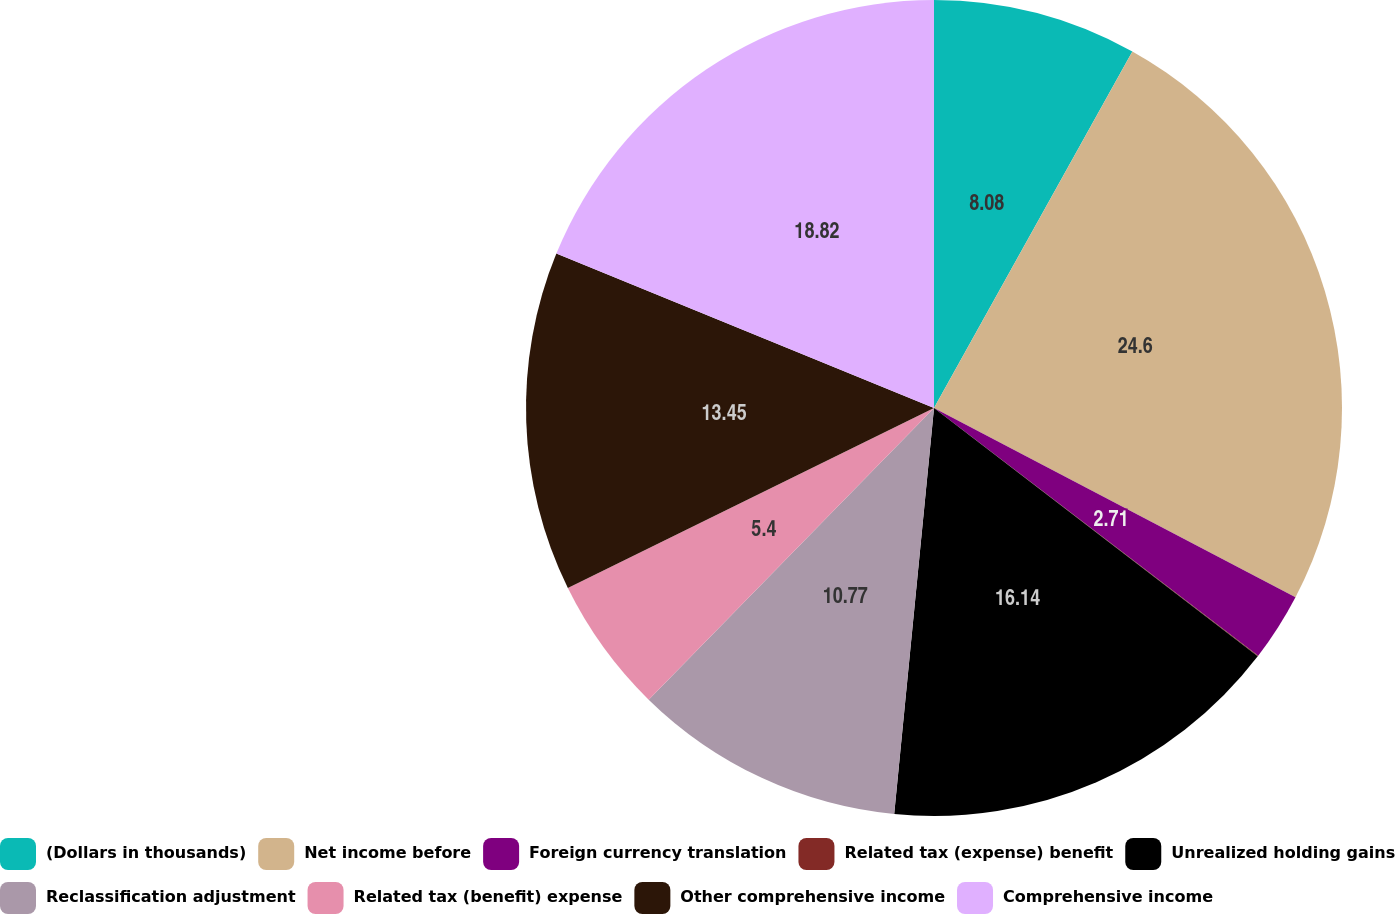Convert chart to OTSL. <chart><loc_0><loc_0><loc_500><loc_500><pie_chart><fcel>(Dollars in thousands)<fcel>Net income before<fcel>Foreign currency translation<fcel>Related tax (expense) benefit<fcel>Unrealized holding gains<fcel>Reclassification adjustment<fcel>Related tax (benefit) expense<fcel>Other comprehensive income<fcel>Comprehensive income<nl><fcel>8.08%<fcel>24.59%<fcel>2.71%<fcel>0.03%<fcel>16.14%<fcel>10.77%<fcel>5.4%<fcel>13.45%<fcel>18.82%<nl></chart> 